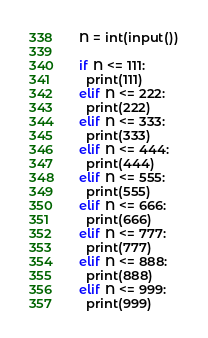<code> <loc_0><loc_0><loc_500><loc_500><_Python_>N = int(input())

if N <= 111:
  print(111)
elif N <= 222:
  print(222)
elif N <= 333:
  print(333)
elif N <= 444:
  print(444)
elif N <= 555:
  print(555)
elif N <= 666:
  print(666)
elif N <= 777:
  print(777)
elif N <= 888:
  print(888)
elif N <= 999:
  print(999)</code> 